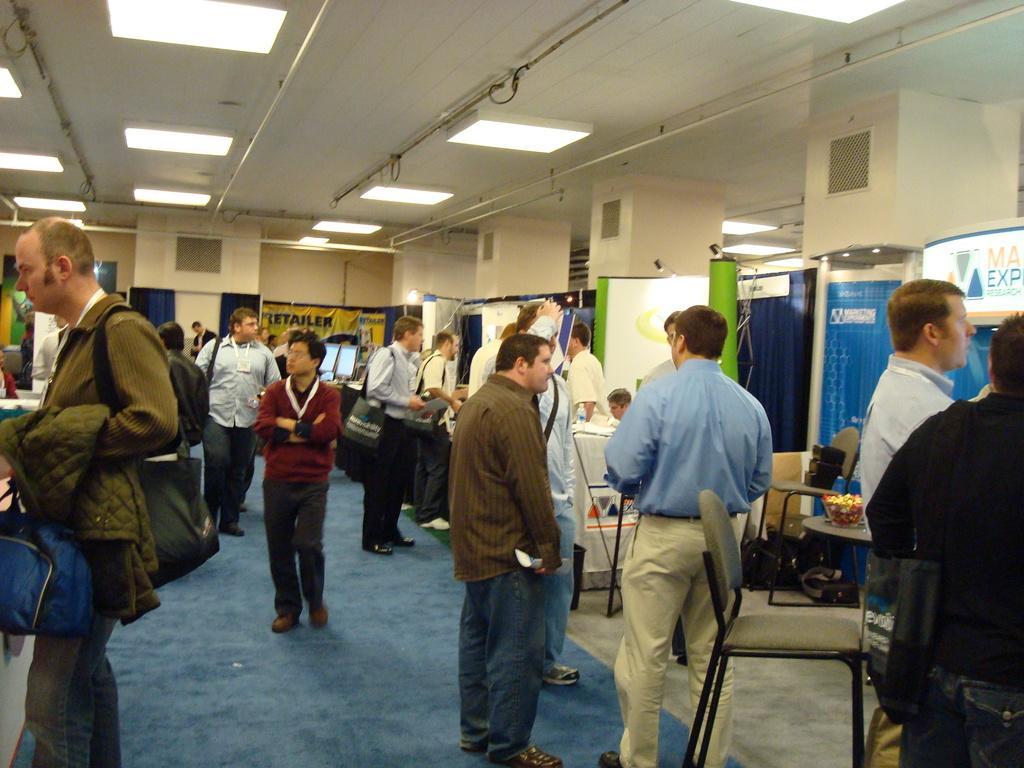How would you summarize this image in a sentence or two? In the middle of the image few people are standing and holding some bags. Behind them there are some chairs and tables and banners. At the top of the image there is ceiling and lights. 